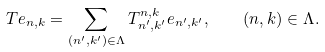<formula> <loc_0><loc_0><loc_500><loc_500>T e _ { n , k } = \sum _ { ( n ^ { \prime } , k ^ { \prime } ) \in \Lambda } T ^ { n , k } _ { n ^ { \prime } , k ^ { \prime } } e _ { n ^ { \prime } , k ^ { \prime } } , \quad ( n , k ) \in \Lambda .</formula> 